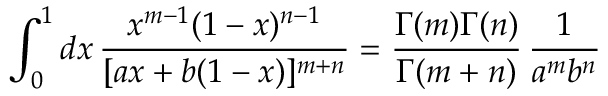Convert formula to latex. <formula><loc_0><loc_0><loc_500><loc_500>\int _ { 0 } ^ { 1 } d x \, { \frac { x ^ { m - 1 } ( 1 - x ) ^ { n - 1 } } { [ a x + b ( 1 - x ) ] ^ { m + n } } } = { \frac { \Gamma ( m ) \Gamma ( n ) } { \Gamma ( m + n ) } } \, { \frac { 1 } { a ^ { m } b ^ { n } } }</formula> 